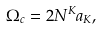<formula> <loc_0><loc_0><loc_500><loc_500>\Omega _ { c } = 2 N ^ { K } a _ { K } ,</formula> 